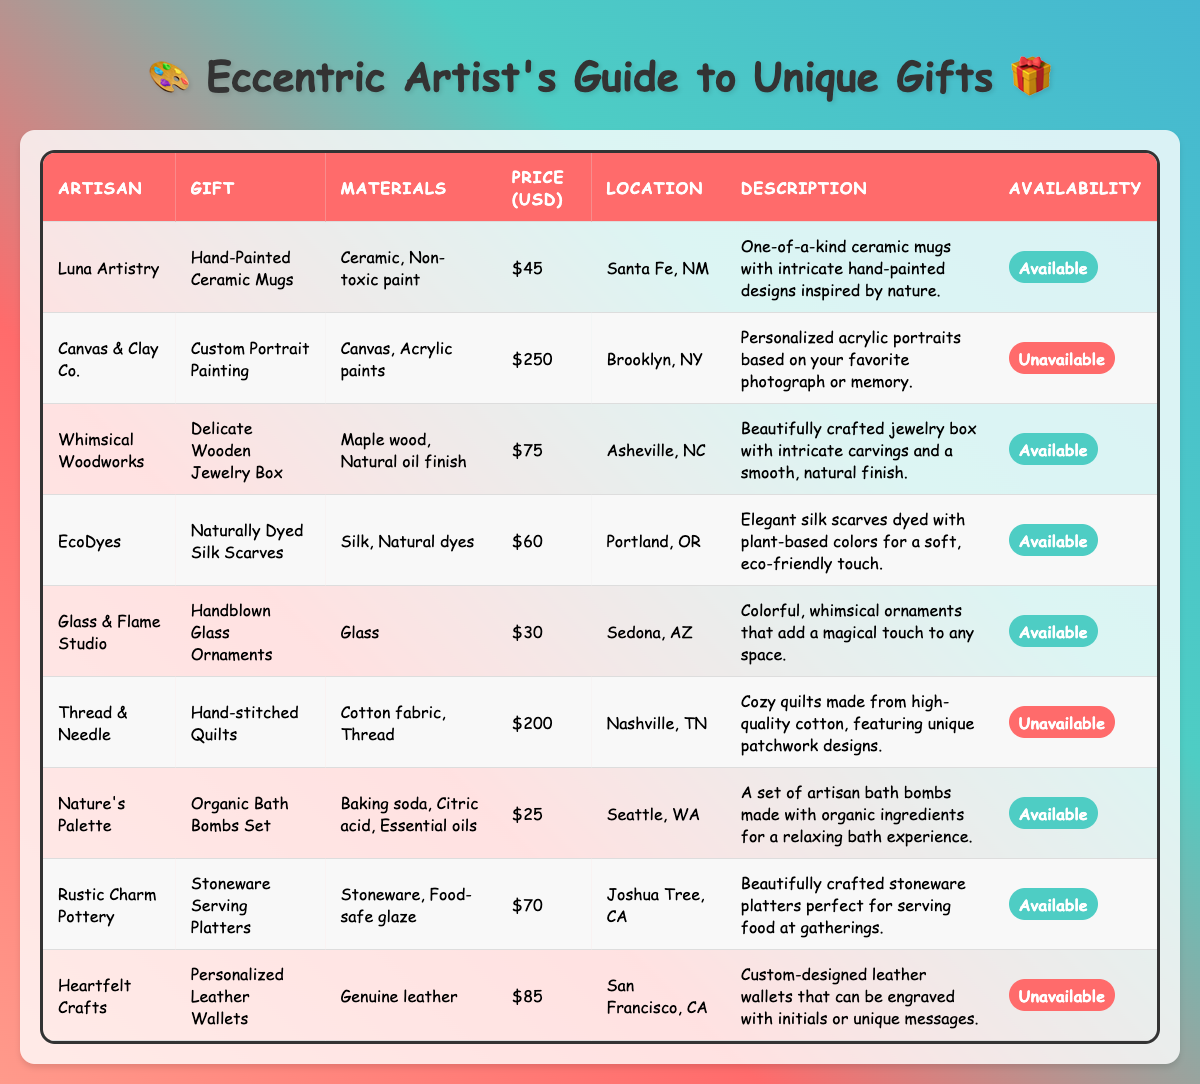What is the price of the Hand-Painted Ceramic Mugs? The price of the Hand-Painted Ceramic Mugs, which are by Luna Artistry, is listed in the table as $45.
Answer: $45 How many gift options are available in the table? The table shows 9 gifts in total, of which 6 have a status of "Available" and 3 are "Unavailable". Therefore, there are 6 gifts available.
Answer: 6 What materials are used in the Delicate Wooden Jewelry Box? The materials of the Delicate Wooden Jewelry Box, which is by Whimsical Woodworks, are listed as Maple wood and Natural oil finish.
Answer: Maple wood and Natural oil finish Which artisan offers the most expensive gift? The Custom Portrait Painting by Canvas & Clay Co. is the most expensive item at $250. This value is higher than the prices of all other items listed.
Answer: Canvas & Clay Co Is the Organic Bath Bombs Set available? Yes, the availability of the Organic Bath Bombs Set is marked as "Available" in the table.
Answer: Yes What is the total price of the available gifts? To find the total price of the available gifts, we sum the prices: $45 (Hand-Painted Ceramic Mugs) + $75 (Delicate Wooden Jewelry Box) + $60 (Naturally Dyed Silk Scarves) + $30 (Handblown Glass Ornaments) + $25 (Organic Bath Bombs Set) + $70 (Stoneware Serving Platters) = $305.
Answer: $305 Which artisan is located in Asheville, NC? The table shows that Whimsical Woodworks is located in Asheville, NC, and they offer the Delicate Wooden Jewelry Box.
Answer: Whimsical Woodworks How many gifts are under $100? The gifts under $100 listed are the Hand-Painted Ceramic Mugs ($45), Delicate Wooden Jewelry Box ($75), Naturally Dyed Silk Scarves ($60), Handblown Glass Ornaments ($30), and Organic Bath Bombs Set ($25), totaling 5 gifts.
Answer: 5 Are there any gifts made of glass? Yes, the Handblown Glass Ornaments are made of glass, as stated in the description of the item in the table.
Answer: Yes Which unique gift has a description about nature? The Hand-Painted Ceramic Mugs by Luna Artistry has a description that mentions intricate hand-painted designs inspired by nature.
Answer: Hand-Painted Ceramic Mugs 